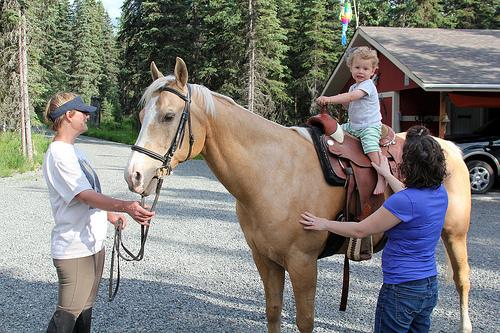How would you describe the saddle on the horse? The saddle is brown and black and has a horn, stirrups, and a hand on it. State the type of area this image appears to be taken in. The image seems to be taken in a countryside setting with a gravel parking lot. Identify the primary activity taking place in the image and who is involved. A little girl is riding a horse while a woman, who is leading the horse, holds the bridle and looks at the kid. What is the woman wearing on her head, and what color is it? The woman is wearing a blue visor on her head. Mention some key objects in the image's background. There is a red barn, a colorful windsock hung on a building, and a car parked in a gravel parking lot in the background. Analyze the image and describe the emotions or feelings it evokes. The image evokes a sense of familial bonding, care, and trust between the woman, the little girl, and the horse. What is a notable aspect of the little girl's appearance? The little girl is a blonde kid with no shoes, sitting on the saddle. Examine the horse and provide a brief description of its face. The horse has a white design on its face and looks sleepy. Explain the role of the woman in this image. The woman is leading the horse, holding the bridle, and looking at the little girl riding the horse, ensuring the child's safety. Count and describe the different objects in the scene related to the woman's outfit. The woman is wearing a blue shirt, blue jeans, and a blue visor. Point out the type of shirt worn by the woman in the image. A white shirt with a picture on the front Can you find the green tractor parked near the barn? What color are its wheels? A green tractor is not included in the provided object list, making it a misleading instruction because the tractor is not present in the image. What item is hung on the old-fashioned country home? An old-fashioned dinner bell Who looks scared in the image? A scared looking boy Where is the grandfather clock positioned inside the red barn? Describe its appearance. A grandfather clock is not mentioned in the given object list, so this instruction is misleading as the object does not exist in the image. Spot the flock of birds flying above the red barn and count how many there are. No flock of birds is mentioned in the object list, making this a misleading instruction because the birds are not present in the image. Describe the horse's mane. The horse has a white mane. What is the mother doing to support the little girl on the horse? Holding her daughter's leg What color of shirt is the woman wearing? Blue What is the surface type of the driveway? Gravel and pebbles What is the lady wearing on her head? A black cap What is the attire of the little girl riding the horse? Blonde kid with no shoes Describe the action involving the woman, the little girl, and the horse. The woman is leading the horse while the little girl is riding it. Which of the following is true about the woman's headgear? a) She is wearing a hat. b) She is wearing a visor. c) She is wearing a helmet. b) She is wearing a visor. Give a brief description of the parking lot in the image. A gravel parking lot with a car parked Tell me how the little girl sitting on the horse is being supported. The mom is holding her daughter's leg for support. What feature can be seen on the front porch of the country home? A scarlet awning What connects the saddle to the rider's feet? Stirrups Identify the object that is controlled by the woman to direct the horse. The reins What kind of animal is in the foreground of the image? A tan horse What is notable about the horse's face? It has a white design on its face. Find the football lying on the gravel parking lot and tell us its color. There is no information about a football in the provided object list, which makes this instruction misleading as the object is not available in the image. Locate the purple umbrella next to the horse and describe its design. There is no mention of a purple umbrella in the provided object list, making it a misleading instruction as this object does not exist in the image. What is on the saddle of the horse? A horn Where is the windsock located in the image? Hung on the building Identify the young boy holding a red balloon near the gravel driveway and note his expression. There is no information about a young boy holding a red balloon in the given object list, thus this instruction is misleading as this object is not available in the image. 